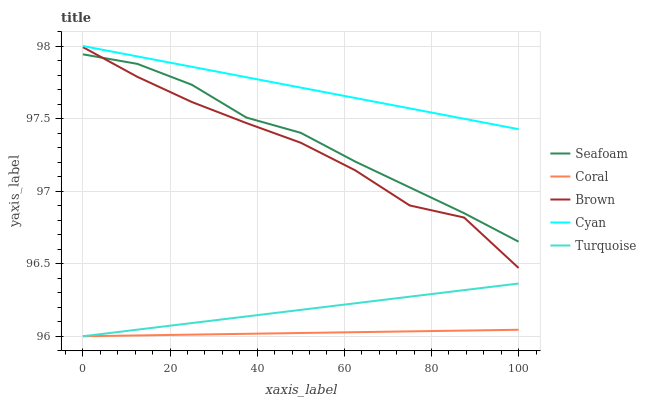Does Coral have the minimum area under the curve?
Answer yes or no. Yes. Does Cyan have the maximum area under the curve?
Answer yes or no. Yes. Does Turquoise have the minimum area under the curve?
Answer yes or no. No. Does Turquoise have the maximum area under the curve?
Answer yes or no. No. Is Coral the smoothest?
Answer yes or no. Yes. Is Brown the roughest?
Answer yes or no. Yes. Is Turquoise the smoothest?
Answer yes or no. No. Is Turquoise the roughest?
Answer yes or no. No. Does Coral have the lowest value?
Answer yes or no. Yes. Does Seafoam have the lowest value?
Answer yes or no. No. Does Cyan have the highest value?
Answer yes or no. Yes. Does Turquoise have the highest value?
Answer yes or no. No. Is Coral less than Cyan?
Answer yes or no. Yes. Is Brown greater than Turquoise?
Answer yes or no. Yes. Does Seafoam intersect Brown?
Answer yes or no. Yes. Is Seafoam less than Brown?
Answer yes or no. No. Is Seafoam greater than Brown?
Answer yes or no. No. Does Coral intersect Cyan?
Answer yes or no. No. 